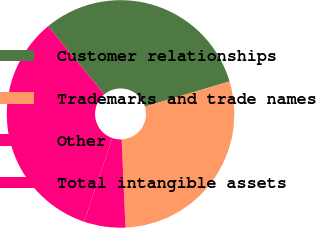Convert chart. <chart><loc_0><loc_0><loc_500><loc_500><pie_chart><fcel>Customer relationships<fcel>Trademarks and trade names<fcel>Other<fcel>Total intangible assets<nl><fcel>31.37%<fcel>28.93%<fcel>5.9%<fcel>33.81%<nl></chart> 